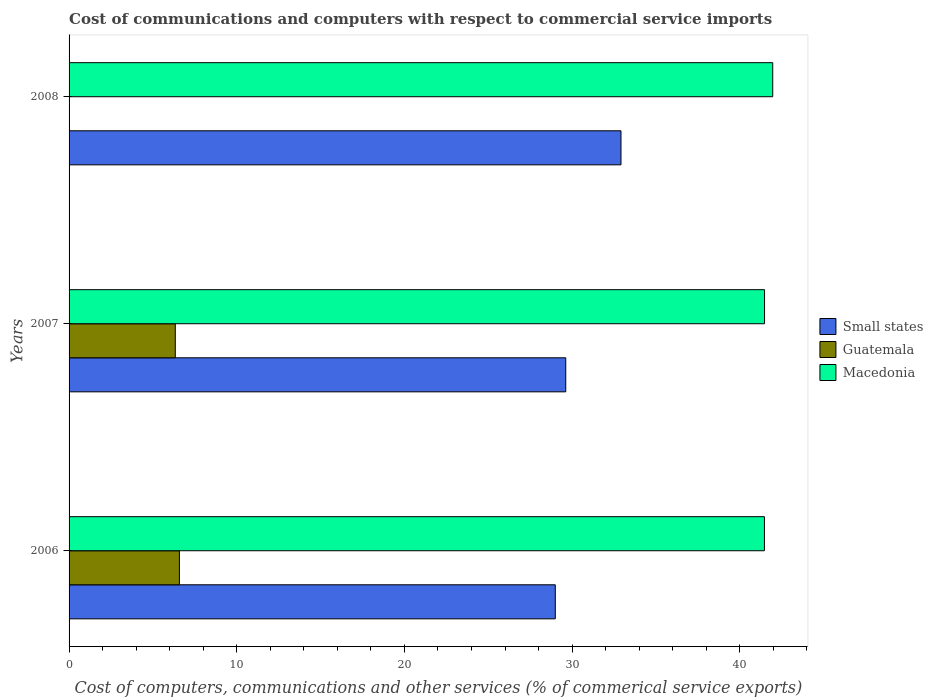How many different coloured bars are there?
Provide a short and direct response. 3. How many groups of bars are there?
Make the answer very short. 3. In how many cases, is the number of bars for a given year not equal to the number of legend labels?
Give a very brief answer. 1. What is the cost of communications and computers in Macedonia in 2006?
Make the answer very short. 41.47. Across all years, what is the maximum cost of communications and computers in Guatemala?
Your answer should be very brief. 6.58. Across all years, what is the minimum cost of communications and computers in Small states?
Provide a succinct answer. 29. What is the total cost of communications and computers in Small states in the graph?
Offer a very short reply. 91.54. What is the difference between the cost of communications and computers in Macedonia in 2007 and that in 2008?
Your response must be concise. -0.49. What is the difference between the cost of communications and computers in Small states in 2006 and the cost of communications and computers in Guatemala in 2008?
Your response must be concise. 29. What is the average cost of communications and computers in Small states per year?
Offer a very short reply. 30.51. In the year 2008, what is the difference between the cost of communications and computers in Small states and cost of communications and computers in Macedonia?
Provide a succinct answer. -9.05. In how many years, is the cost of communications and computers in Small states greater than 16 %?
Your response must be concise. 3. What is the ratio of the cost of communications and computers in Small states in 2007 to that in 2008?
Provide a short and direct response. 0.9. What is the difference between the highest and the second highest cost of communications and computers in Macedonia?
Make the answer very short. 0.49. What is the difference between the highest and the lowest cost of communications and computers in Macedonia?
Make the answer very short. 0.5. How many bars are there?
Your answer should be compact. 8. How many years are there in the graph?
Offer a terse response. 3. Does the graph contain any zero values?
Keep it short and to the point. Yes. Does the graph contain grids?
Make the answer very short. No. Where does the legend appear in the graph?
Keep it short and to the point. Center right. How are the legend labels stacked?
Provide a short and direct response. Vertical. What is the title of the graph?
Make the answer very short. Cost of communications and computers with respect to commercial service imports. What is the label or title of the X-axis?
Your answer should be very brief. Cost of computers, communications and other services (% of commerical service exports). What is the label or title of the Y-axis?
Provide a succinct answer. Years. What is the Cost of computers, communications and other services (% of commerical service exports) in Small states in 2006?
Offer a terse response. 29. What is the Cost of computers, communications and other services (% of commerical service exports) of Guatemala in 2006?
Provide a succinct answer. 6.58. What is the Cost of computers, communications and other services (% of commerical service exports) of Macedonia in 2006?
Provide a succinct answer. 41.47. What is the Cost of computers, communications and other services (% of commerical service exports) of Small states in 2007?
Your response must be concise. 29.62. What is the Cost of computers, communications and other services (% of commerical service exports) in Guatemala in 2007?
Provide a short and direct response. 6.34. What is the Cost of computers, communications and other services (% of commerical service exports) of Macedonia in 2007?
Your response must be concise. 41.48. What is the Cost of computers, communications and other services (% of commerical service exports) in Small states in 2008?
Keep it short and to the point. 32.92. What is the Cost of computers, communications and other services (% of commerical service exports) in Guatemala in 2008?
Offer a very short reply. 0. What is the Cost of computers, communications and other services (% of commerical service exports) of Macedonia in 2008?
Your response must be concise. 41.97. Across all years, what is the maximum Cost of computers, communications and other services (% of commerical service exports) of Small states?
Your response must be concise. 32.92. Across all years, what is the maximum Cost of computers, communications and other services (% of commerical service exports) of Guatemala?
Give a very brief answer. 6.58. Across all years, what is the maximum Cost of computers, communications and other services (% of commerical service exports) of Macedonia?
Your answer should be compact. 41.97. Across all years, what is the minimum Cost of computers, communications and other services (% of commerical service exports) of Small states?
Offer a terse response. 29. Across all years, what is the minimum Cost of computers, communications and other services (% of commerical service exports) of Guatemala?
Your answer should be very brief. 0. Across all years, what is the minimum Cost of computers, communications and other services (% of commerical service exports) of Macedonia?
Keep it short and to the point. 41.47. What is the total Cost of computers, communications and other services (% of commerical service exports) of Small states in the graph?
Offer a terse response. 91.54. What is the total Cost of computers, communications and other services (% of commerical service exports) in Guatemala in the graph?
Give a very brief answer. 12.92. What is the total Cost of computers, communications and other services (% of commerical service exports) in Macedonia in the graph?
Provide a succinct answer. 124.92. What is the difference between the Cost of computers, communications and other services (% of commerical service exports) in Small states in 2006 and that in 2007?
Provide a succinct answer. -0.62. What is the difference between the Cost of computers, communications and other services (% of commerical service exports) in Guatemala in 2006 and that in 2007?
Make the answer very short. 0.25. What is the difference between the Cost of computers, communications and other services (% of commerical service exports) in Macedonia in 2006 and that in 2007?
Provide a succinct answer. -0.01. What is the difference between the Cost of computers, communications and other services (% of commerical service exports) in Small states in 2006 and that in 2008?
Your answer should be very brief. -3.92. What is the difference between the Cost of computers, communications and other services (% of commerical service exports) of Macedonia in 2006 and that in 2008?
Give a very brief answer. -0.49. What is the difference between the Cost of computers, communications and other services (% of commerical service exports) in Small states in 2007 and that in 2008?
Your answer should be compact. -3.29. What is the difference between the Cost of computers, communications and other services (% of commerical service exports) in Macedonia in 2007 and that in 2008?
Offer a very short reply. -0.49. What is the difference between the Cost of computers, communications and other services (% of commerical service exports) in Small states in 2006 and the Cost of computers, communications and other services (% of commerical service exports) in Guatemala in 2007?
Your answer should be very brief. 22.66. What is the difference between the Cost of computers, communications and other services (% of commerical service exports) in Small states in 2006 and the Cost of computers, communications and other services (% of commerical service exports) in Macedonia in 2007?
Give a very brief answer. -12.48. What is the difference between the Cost of computers, communications and other services (% of commerical service exports) of Guatemala in 2006 and the Cost of computers, communications and other services (% of commerical service exports) of Macedonia in 2007?
Ensure brevity in your answer.  -34.9. What is the difference between the Cost of computers, communications and other services (% of commerical service exports) in Small states in 2006 and the Cost of computers, communications and other services (% of commerical service exports) in Macedonia in 2008?
Offer a terse response. -12.97. What is the difference between the Cost of computers, communications and other services (% of commerical service exports) in Guatemala in 2006 and the Cost of computers, communications and other services (% of commerical service exports) in Macedonia in 2008?
Give a very brief answer. -35.39. What is the difference between the Cost of computers, communications and other services (% of commerical service exports) in Small states in 2007 and the Cost of computers, communications and other services (% of commerical service exports) in Macedonia in 2008?
Make the answer very short. -12.34. What is the difference between the Cost of computers, communications and other services (% of commerical service exports) of Guatemala in 2007 and the Cost of computers, communications and other services (% of commerical service exports) of Macedonia in 2008?
Offer a terse response. -35.63. What is the average Cost of computers, communications and other services (% of commerical service exports) of Small states per year?
Make the answer very short. 30.51. What is the average Cost of computers, communications and other services (% of commerical service exports) in Guatemala per year?
Make the answer very short. 4.31. What is the average Cost of computers, communications and other services (% of commerical service exports) of Macedonia per year?
Provide a succinct answer. 41.64. In the year 2006, what is the difference between the Cost of computers, communications and other services (% of commerical service exports) in Small states and Cost of computers, communications and other services (% of commerical service exports) in Guatemala?
Ensure brevity in your answer.  22.42. In the year 2006, what is the difference between the Cost of computers, communications and other services (% of commerical service exports) in Small states and Cost of computers, communications and other services (% of commerical service exports) in Macedonia?
Give a very brief answer. -12.47. In the year 2006, what is the difference between the Cost of computers, communications and other services (% of commerical service exports) of Guatemala and Cost of computers, communications and other services (% of commerical service exports) of Macedonia?
Offer a very short reply. -34.89. In the year 2007, what is the difference between the Cost of computers, communications and other services (% of commerical service exports) in Small states and Cost of computers, communications and other services (% of commerical service exports) in Guatemala?
Your answer should be compact. 23.29. In the year 2007, what is the difference between the Cost of computers, communications and other services (% of commerical service exports) in Small states and Cost of computers, communications and other services (% of commerical service exports) in Macedonia?
Ensure brevity in your answer.  -11.86. In the year 2007, what is the difference between the Cost of computers, communications and other services (% of commerical service exports) in Guatemala and Cost of computers, communications and other services (% of commerical service exports) in Macedonia?
Keep it short and to the point. -35.14. In the year 2008, what is the difference between the Cost of computers, communications and other services (% of commerical service exports) of Small states and Cost of computers, communications and other services (% of commerical service exports) of Macedonia?
Give a very brief answer. -9.05. What is the ratio of the Cost of computers, communications and other services (% of commerical service exports) of Small states in 2006 to that in 2007?
Ensure brevity in your answer.  0.98. What is the ratio of the Cost of computers, communications and other services (% of commerical service exports) of Guatemala in 2006 to that in 2007?
Your response must be concise. 1.04. What is the ratio of the Cost of computers, communications and other services (% of commerical service exports) of Macedonia in 2006 to that in 2007?
Your answer should be compact. 1. What is the ratio of the Cost of computers, communications and other services (% of commerical service exports) in Small states in 2006 to that in 2008?
Make the answer very short. 0.88. What is the ratio of the Cost of computers, communications and other services (% of commerical service exports) of Small states in 2007 to that in 2008?
Provide a succinct answer. 0.9. What is the ratio of the Cost of computers, communications and other services (% of commerical service exports) of Macedonia in 2007 to that in 2008?
Keep it short and to the point. 0.99. What is the difference between the highest and the second highest Cost of computers, communications and other services (% of commerical service exports) in Small states?
Offer a very short reply. 3.29. What is the difference between the highest and the second highest Cost of computers, communications and other services (% of commerical service exports) of Macedonia?
Give a very brief answer. 0.49. What is the difference between the highest and the lowest Cost of computers, communications and other services (% of commerical service exports) of Small states?
Give a very brief answer. 3.92. What is the difference between the highest and the lowest Cost of computers, communications and other services (% of commerical service exports) of Guatemala?
Your response must be concise. 6.58. What is the difference between the highest and the lowest Cost of computers, communications and other services (% of commerical service exports) in Macedonia?
Keep it short and to the point. 0.49. 